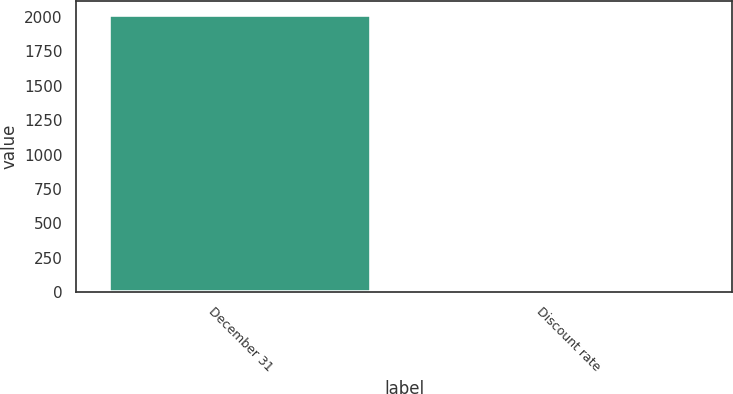<chart> <loc_0><loc_0><loc_500><loc_500><bar_chart><fcel>December 31<fcel>Discount rate<nl><fcel>2013<fcel>4.5<nl></chart> 